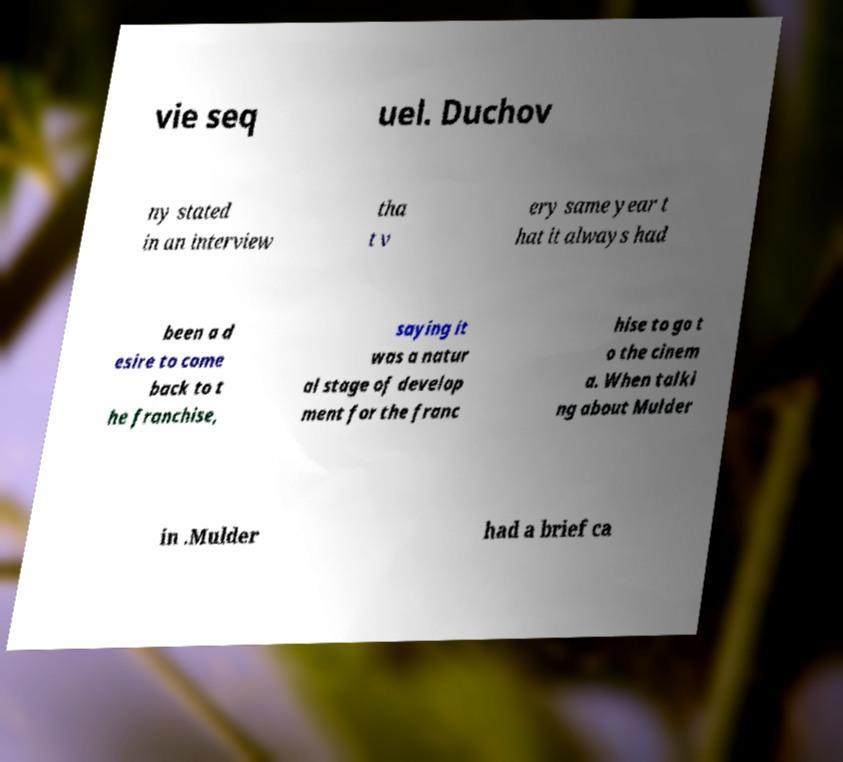Please identify and transcribe the text found in this image. vie seq uel. Duchov ny stated in an interview tha t v ery same year t hat it always had been a d esire to come back to t he franchise, saying it was a natur al stage of develop ment for the franc hise to go t o the cinem a. When talki ng about Mulder in .Mulder had a brief ca 